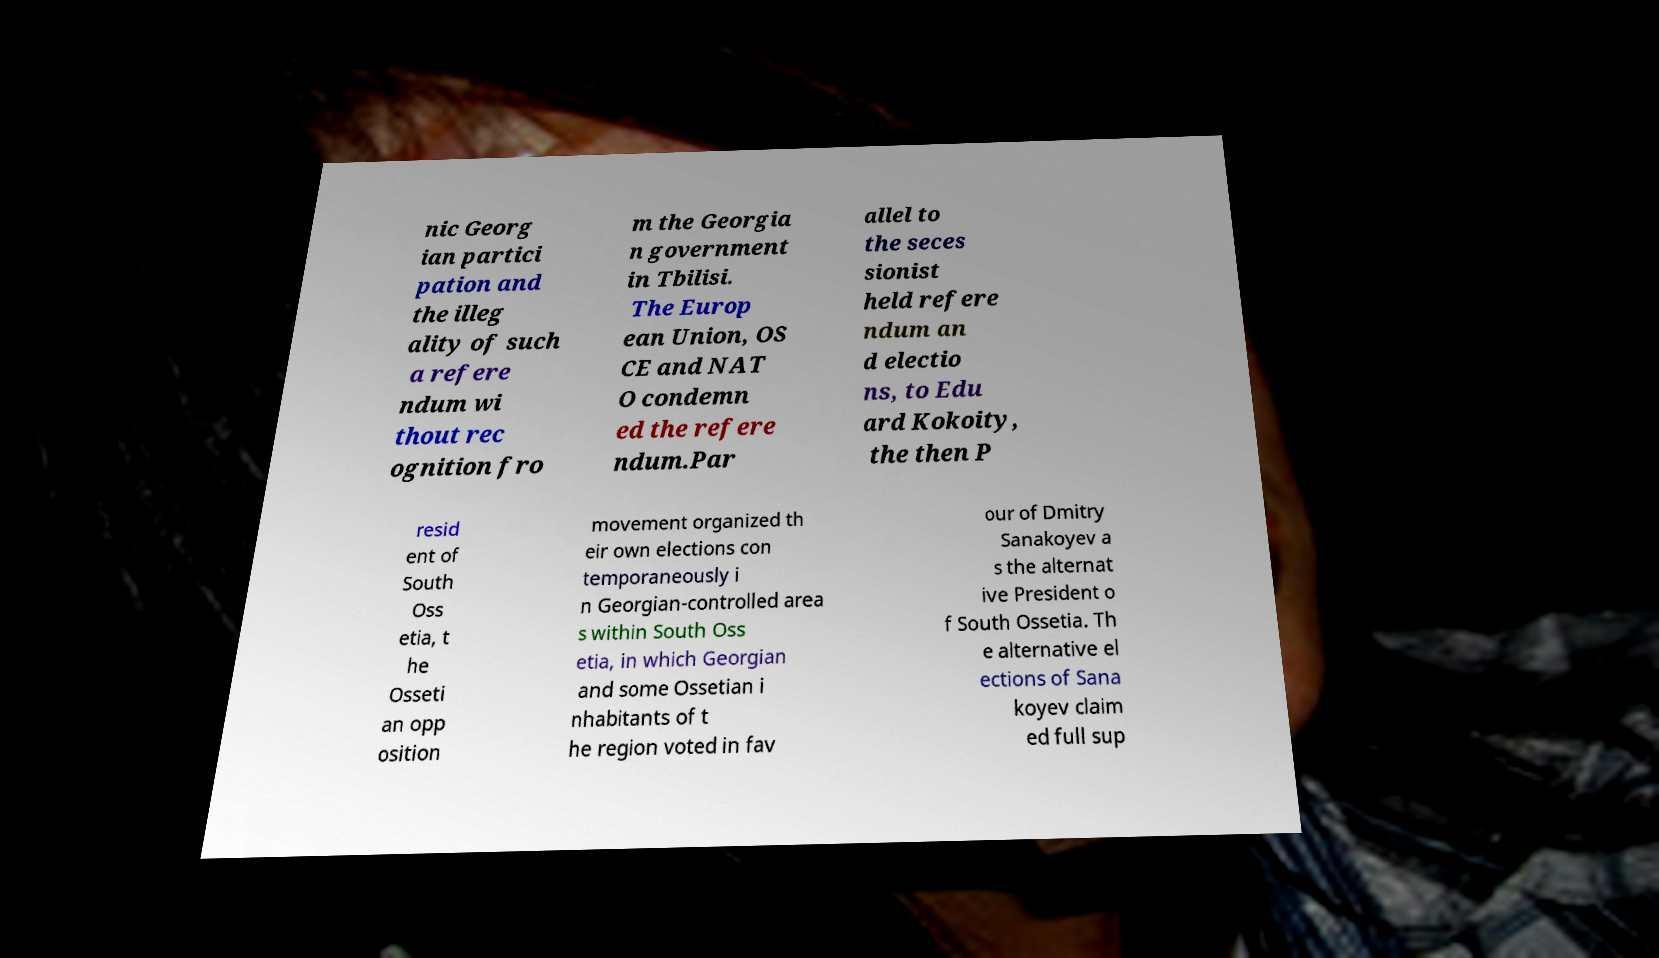Please identify and transcribe the text found in this image. nic Georg ian partici pation and the illeg ality of such a refere ndum wi thout rec ognition fro m the Georgia n government in Tbilisi. The Europ ean Union, OS CE and NAT O condemn ed the refere ndum.Par allel to the seces sionist held refere ndum an d electio ns, to Edu ard Kokoity, the then P resid ent of South Oss etia, t he Osseti an opp osition movement organized th eir own elections con temporaneously i n Georgian-controlled area s within South Oss etia, in which Georgian and some Ossetian i nhabitants of t he region voted in fav our of Dmitry Sanakoyev a s the alternat ive President o f South Ossetia. Th e alternative el ections of Sana koyev claim ed full sup 